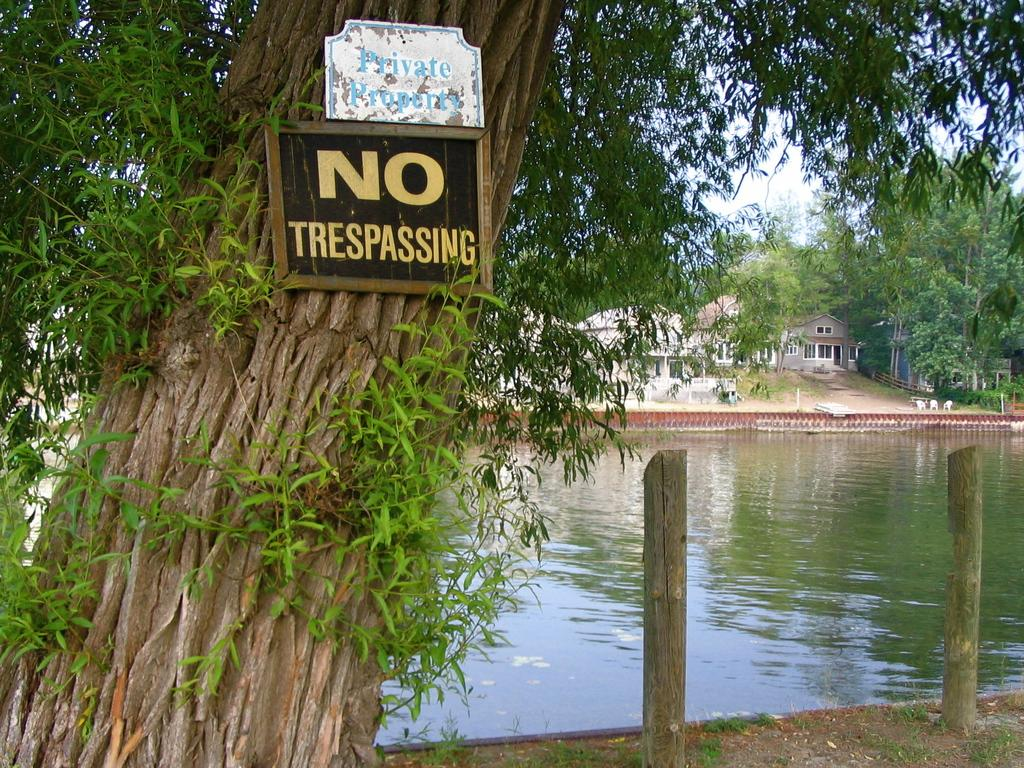What type of structures can be seen in the image? There are houses in the image. What natural elements are present in the image? There are trees and water visible in the image. What objects have text on them in the image? There are boards with text in the image. What type of vertical structures can be seen in the image? There are poles in the image. What is visible in the background of the image? The sky is visible in the background of the image. Can you tell me how many bells are hanging from the poles in the image? There are no bells present in the image; it features houses, trees, water, boards with text, poles, and a visible sky. What color is the chalk used to write on the boards in the image? There is no chalk visible in the image; only the boards with text are present. 